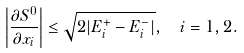<formula> <loc_0><loc_0><loc_500><loc_500>\left | \frac { \partial S ^ { 0 } } { \partial x _ { i } } \right | \leq \sqrt { 2 | E ^ { + } _ { i } - E ^ { - } _ { i } | } , \ \ i = 1 , 2 .</formula> 